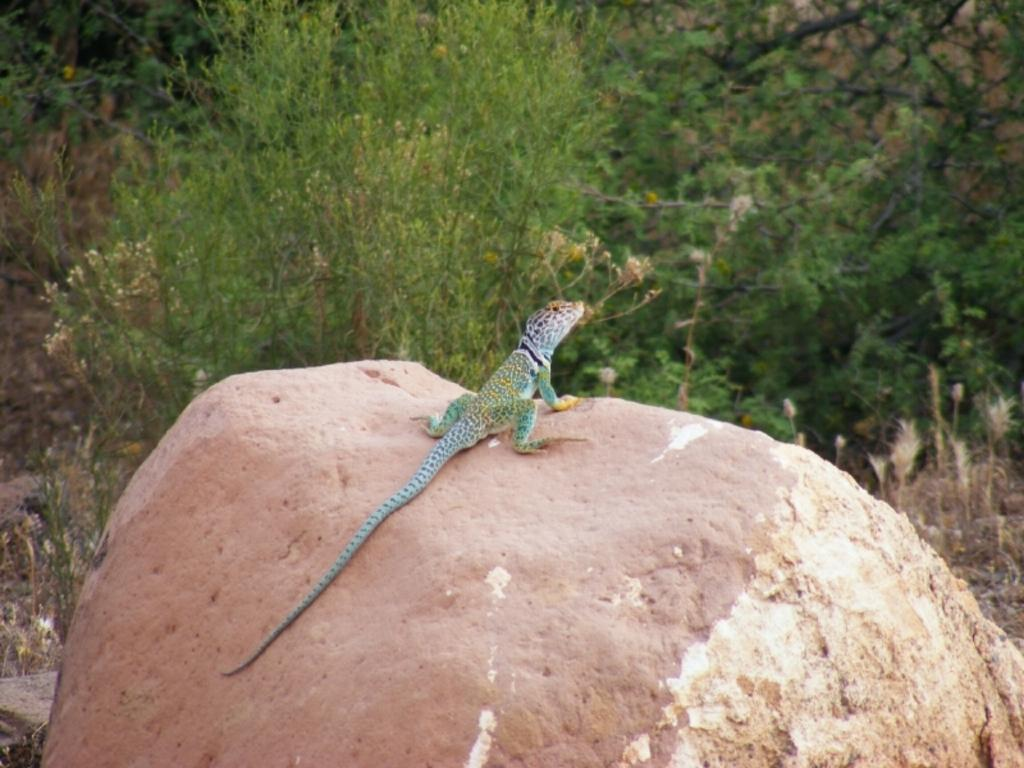What type of animal is in the image? There is a reptile in the image. Where is the reptile located? The reptile is on a rock. What can be seen in the background of the image? There are trees in the background of the image. What design can be seen on the reptile's thought in the image? There is no indication of a reptile having thoughts or a design on them in the image. 